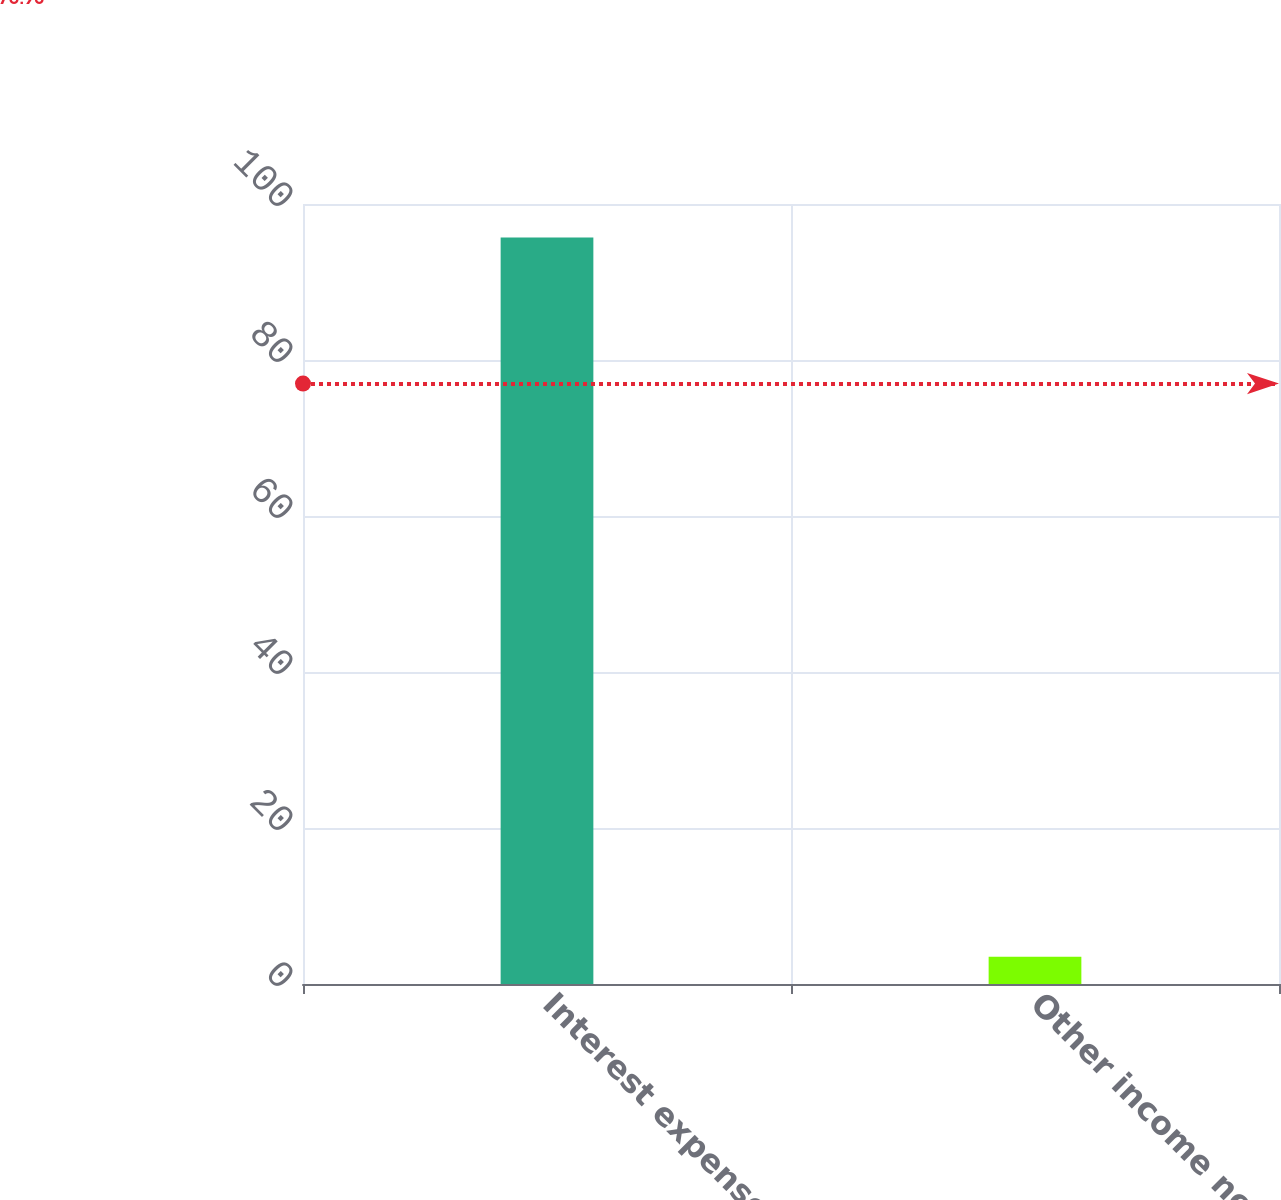<chart> <loc_0><loc_0><loc_500><loc_500><bar_chart><fcel>Interest expense<fcel>Other income net<nl><fcel>95.7<fcel>3.5<nl></chart> 